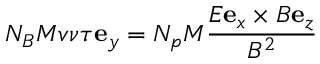<formula> <loc_0><loc_0><loc_500><loc_500>N _ { B } M v \nu \tau e _ { y } = N _ { p } M \frac { E e _ { x } \times B e _ { z } } { B ^ { 2 } }</formula> 